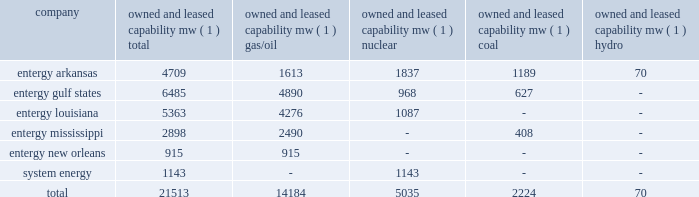Part i item 1 entergy corporation , domestic utility companies , and system energy entergy louisiana holds non-exclusive franchises to provide electric service in approximately 116 incorporated louisiana municipalities .
Most of these franchises have 25-year terms , although six of these municipalities have granted 60-year franchises .
Entergy louisiana also supplies electric service in approximately 353 unincorporated communities , all of which are located in louisiana parishes in which it holds non-exclusive franchises .
Entergy mississippi has received from the mpsc certificates of public convenience and necessity to provide electric service to areas within 45 counties , including a number of municipalities , in western mississippi .
Under mississippi statutory law , such certificates are exclusive .
Entergy mississippi may continue to serve in such municipalities upon payment of a statutory franchise fee , regardless of whether an original municipal franchise is still in existence .
Entergy new orleans provides electric and gas service in the city of new orleans pursuant to city ordinances ( except electric service in algiers , which is provided by entergy louisiana ) .
These ordinances contain a continuing option for the city of new orleans to purchase entergy new orleans' electric and gas utility properties .
The business of system energy is limited to wholesale power sales .
It has no distribution franchises .
Property and other generation resources generating stations the total capability of the generating stations owned and leased by the domestic utility companies and system energy as of december 31 , 2004 , is indicated below: .
( 1 ) "owned and leased capability" is the dependable load carrying capability as demonstrated under actual operating conditions based on the primary fuel ( assuming no curtailments ) that each station was designed to utilize .
Entergy's load and capacity projections are reviewed periodically to assess the need and timing for additional generating capacity and interconnections .
These reviews consider existing and projected demand , the availability and price of power , the location of new loads , and economy .
Peak load in the u.s .
Utility service territory is typically around 21000 mw , with minimum load typically around 9000 mw .
Allowing for an adequate reserve margin , entergy has been short approximately 3000 mw during the summer peak load period .
In addition to its net short position at summer peak , entergy considers its generation in three categories : ( 1 ) baseload ( e.g .
Coal and nuclear ) ; ( 2 ) load-following ( e.g .
Combined cycle gas-fired ) ; and ( 3 ) peaking .
The relative supply and demand for these categories of generation vary by region of the entergy system .
For example , the north end of its system has more baseload coal and nuclear generation than regional demand requires , but is short load-following or intermediate generation .
In the south end of the entergy system , load would be more effectively served if gas- fired intermediate resources already in place were supplemented with additional solid fuel baseload generation. .
What portion of total capability of entergy corporation is generated by entergy gulf states? 
Computations: (6485 / 21513)
Answer: 0.30145. Part i item 1 entergy corporation , domestic utility companies , and system energy entergy louisiana holds non-exclusive franchises to provide electric service in approximately 116 incorporated louisiana municipalities .
Most of these franchises have 25-year terms , although six of these municipalities have granted 60-year franchises .
Entergy louisiana also supplies electric service in approximately 353 unincorporated communities , all of which are located in louisiana parishes in which it holds non-exclusive franchises .
Entergy mississippi has received from the mpsc certificates of public convenience and necessity to provide electric service to areas within 45 counties , including a number of municipalities , in western mississippi .
Under mississippi statutory law , such certificates are exclusive .
Entergy mississippi may continue to serve in such municipalities upon payment of a statutory franchise fee , regardless of whether an original municipal franchise is still in existence .
Entergy new orleans provides electric and gas service in the city of new orleans pursuant to city ordinances ( except electric service in algiers , which is provided by entergy louisiana ) .
These ordinances contain a continuing option for the city of new orleans to purchase entergy new orleans' electric and gas utility properties .
The business of system energy is limited to wholesale power sales .
It has no distribution franchises .
Property and other generation resources generating stations the total capability of the generating stations owned and leased by the domestic utility companies and system energy as of december 31 , 2004 , is indicated below: .
( 1 ) "owned and leased capability" is the dependable load carrying capability as demonstrated under actual operating conditions based on the primary fuel ( assuming no curtailments ) that each station was designed to utilize .
Entergy's load and capacity projections are reviewed periodically to assess the need and timing for additional generating capacity and interconnections .
These reviews consider existing and projected demand , the availability and price of power , the location of new loads , and economy .
Peak load in the u.s .
Utility service territory is typically around 21000 mw , with minimum load typically around 9000 mw .
Allowing for an adequate reserve margin , entergy has been short approximately 3000 mw during the summer peak load period .
In addition to its net short position at summer peak , entergy considers its generation in three categories : ( 1 ) baseload ( e.g .
Coal and nuclear ) ; ( 2 ) load-following ( e.g .
Combined cycle gas-fired ) ; and ( 3 ) peaking .
The relative supply and demand for these categories of generation vary by region of the entergy system .
For example , the north end of its system has more baseload coal and nuclear generation than regional demand requires , but is short load-following or intermediate generation .
In the south end of the entergy system , load would be more effectively served if gas- fired intermediate resources already in place were supplemented with additional solid fuel baseload generation. .
What portion of total capability of entergy corporation is generated by entergy arkansas? 
Computations: (4709 / 21513)
Answer: 0.21889. 